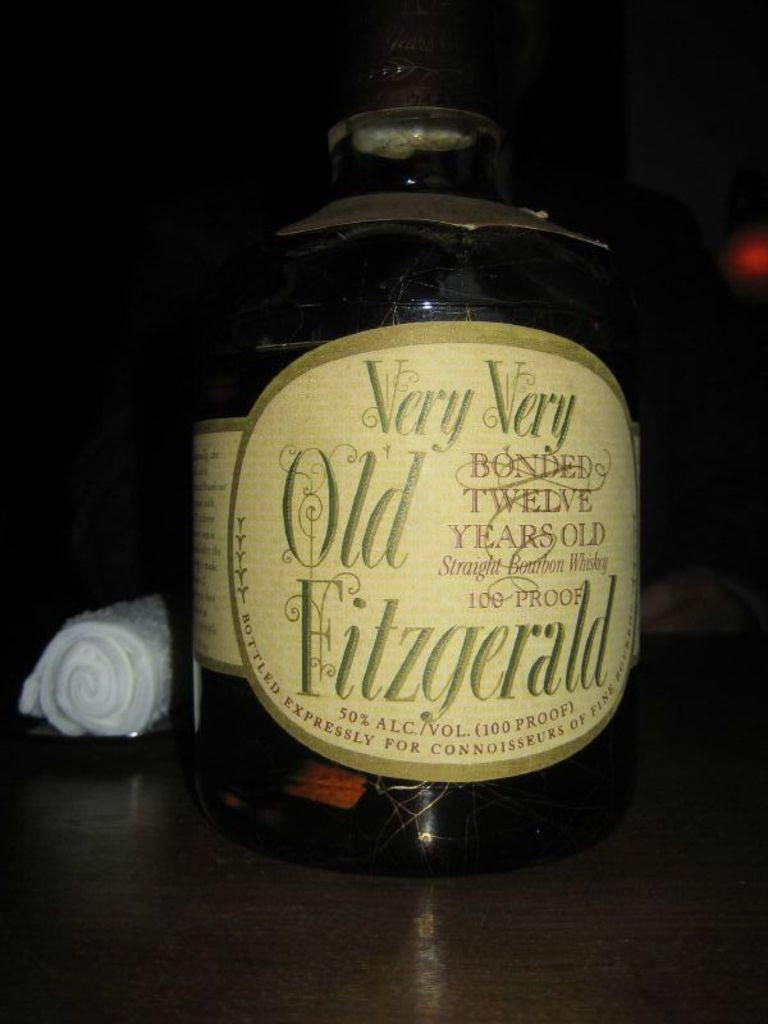<image>
Write a terse but informative summary of the picture. A bottle of Very Very Old Fitzgerald is stitting on a table. 